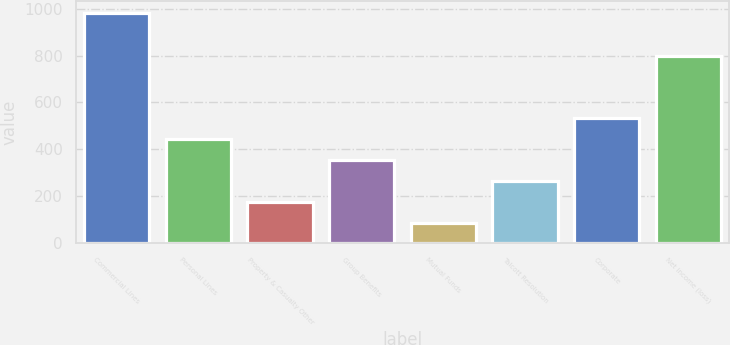Convert chart to OTSL. <chart><loc_0><loc_0><loc_500><loc_500><bar_chart><fcel>Commercial Lines<fcel>Personal Lines<fcel>Property & Casualty Other<fcel>Group Benefits<fcel>Mutual Funds<fcel>Talcott Resolution<fcel>Corporate<fcel>Net income (loss)<nl><fcel>983<fcel>445.4<fcel>176.6<fcel>355.8<fcel>87<fcel>266.2<fcel>535<fcel>798<nl></chart> 